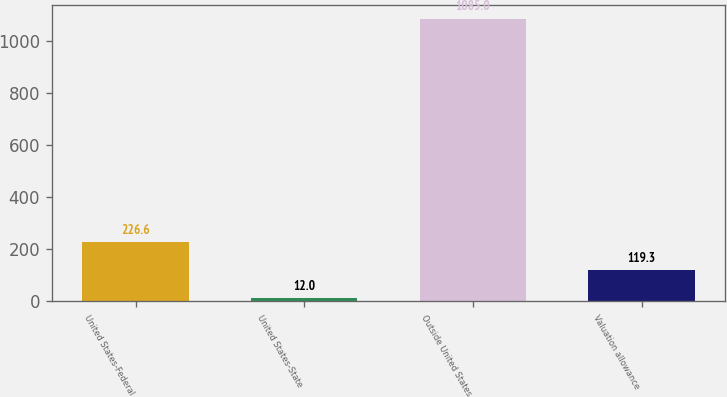Convert chart to OTSL. <chart><loc_0><loc_0><loc_500><loc_500><bar_chart><fcel>United States-Federal<fcel>United States-State<fcel>Outside United States<fcel>Valuation allowance<nl><fcel>226.6<fcel>12<fcel>1085<fcel>119.3<nl></chart> 